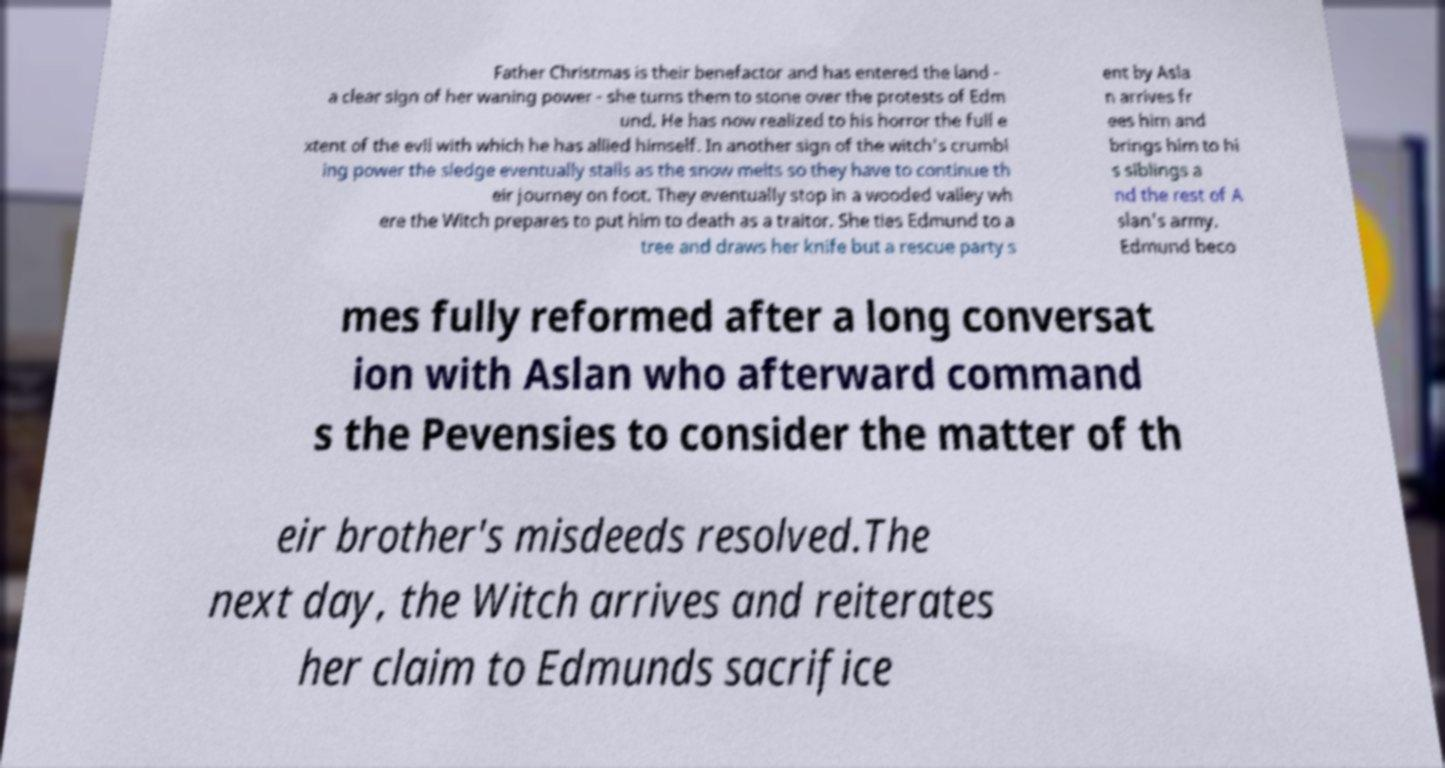What messages or text are displayed in this image? I need them in a readable, typed format. Father Christmas is their benefactor and has entered the land - a clear sign of her waning power - she turns them to stone over the protests of Edm und. He has now realized to his horror the full e xtent of the evil with which he has allied himself. In another sign of the witch's crumbl ing power the sledge eventually stalls as the snow melts so they have to continue th eir journey on foot. They eventually stop in a wooded valley wh ere the Witch prepares to put him to death as a traitor. She ties Edmund to a tree and draws her knife but a rescue party s ent by Asla n arrives fr ees him and brings him to hi s siblings a nd the rest of A slan's army. Edmund beco mes fully reformed after a long conversat ion with Aslan who afterward command s the Pevensies to consider the matter of th eir brother's misdeeds resolved.The next day, the Witch arrives and reiterates her claim to Edmunds sacrifice 